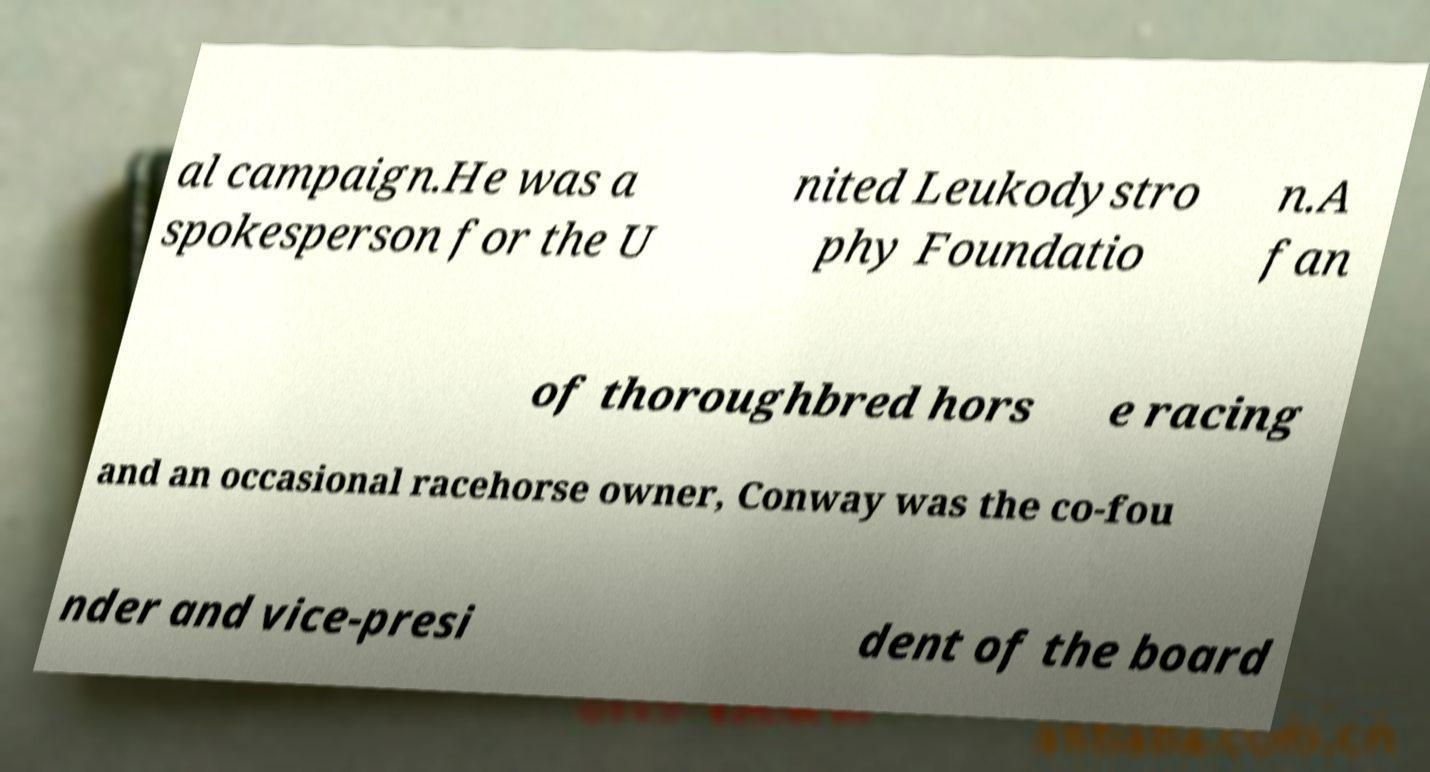What messages or text are displayed in this image? I need them in a readable, typed format. al campaign.He was a spokesperson for the U nited Leukodystro phy Foundatio n.A fan of thoroughbred hors e racing and an occasional racehorse owner, Conway was the co-fou nder and vice-presi dent of the board 